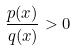Convert formula to latex. <formula><loc_0><loc_0><loc_500><loc_500>\frac { p ( x ) } { q ( x ) } > 0</formula> 